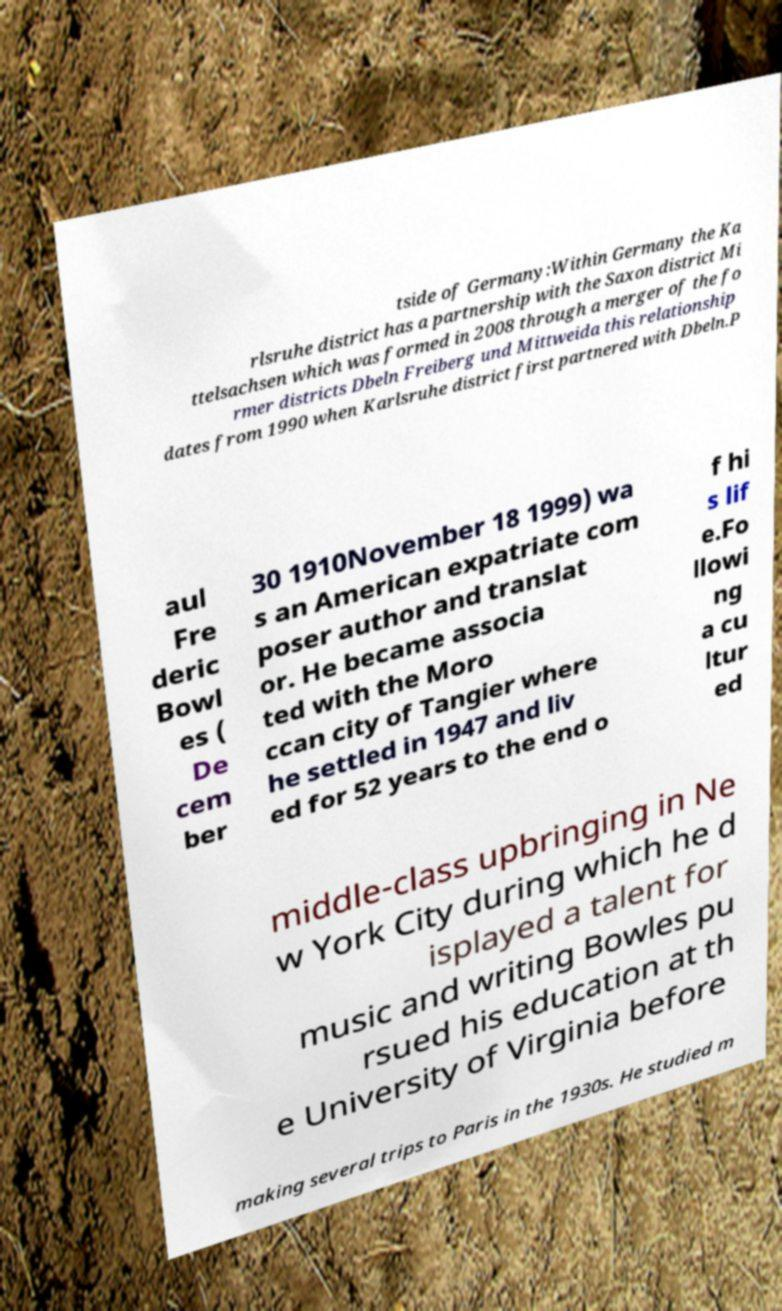Please identify and transcribe the text found in this image. tside of Germany:Within Germany the Ka rlsruhe district has a partnership with the Saxon district Mi ttelsachsen which was formed in 2008 through a merger of the fo rmer districts Dbeln Freiberg und Mittweida this relationship dates from 1990 when Karlsruhe district first partnered with Dbeln.P aul Fre deric Bowl es ( De cem ber 30 1910November 18 1999) wa s an American expatriate com poser author and translat or. He became associa ted with the Moro ccan city of Tangier where he settled in 1947 and liv ed for 52 years to the end o f hi s lif e.Fo llowi ng a cu ltur ed middle-class upbringing in Ne w York City during which he d isplayed a talent for music and writing Bowles pu rsued his education at th e University of Virginia before making several trips to Paris in the 1930s. He studied m 